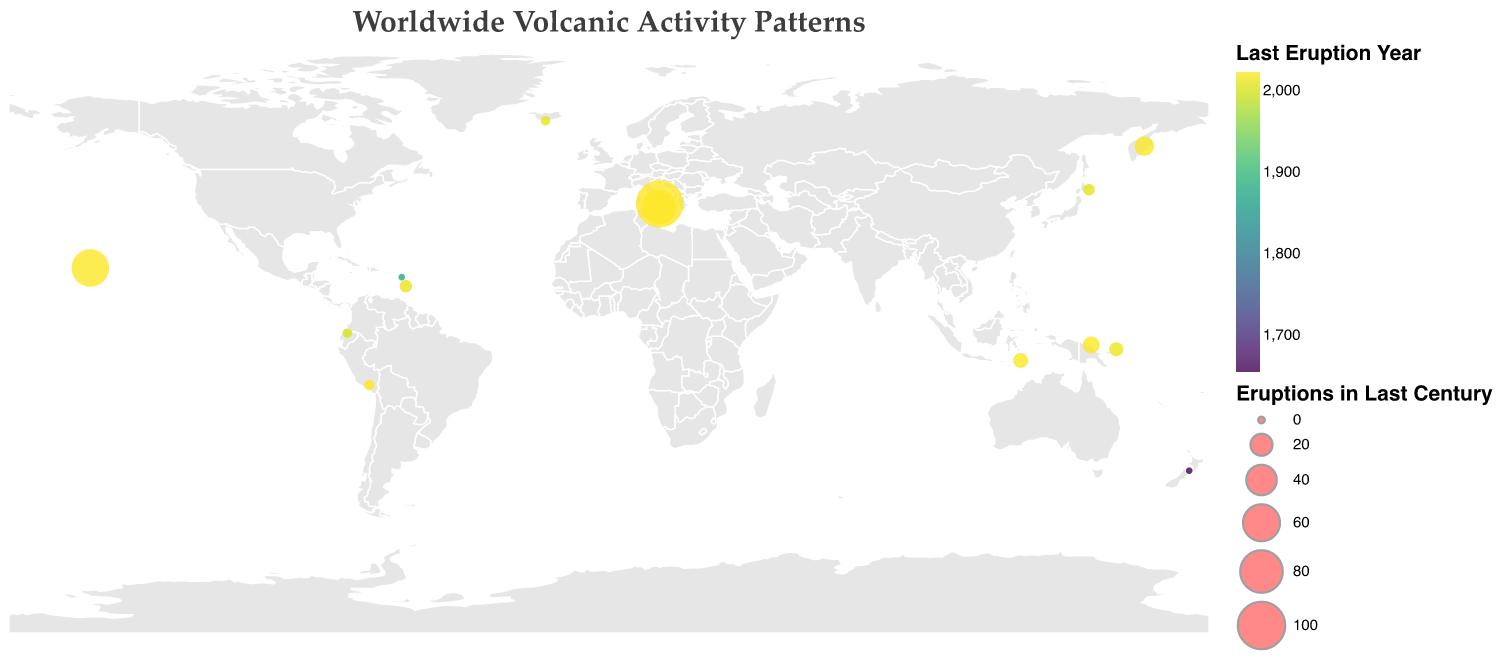Which volcano had the most eruptions in the last century? By observing the size of the circles, the largest circle represents the volcano with the most eruptions. The largest circle is for Stromboli in Italy, with "Continuous" eruptions.
Answer: Stromboli Which volcano last erupted in 2010? By looking at the tooltip or the color scale indicating the eruption year, we find Soufriere Hills in Montserrat and Eyjafjallajökull in Iceland both last erupted in 2010.
Answer: Soufriere Hills, Eyjafjallajökull How many volcanoes have not erupted in the last century? Zero eruptions are represented by the smallest circles. There are two such small circles, belonging to Taranaki in New Zealand and Morne Diablotins in Dominica.
Answer: 2 Which country has the volcano with the highest eruption frequency? By checking the tooltip and looking for the highest number of eruptions (largest circle) combined with country information, we see that Stromboli in Italy has the highest eruption frequency.
Answer: Italy What is the average number of eruptions in the last century for Papua New Guinea's volcanoes? Papua New Guinea has two volcanoes, Tavurvur and Manam, with 7 and 11 eruptions respectively. The average is calculated as (7 + 11) / 2 = 9.
Answer: 9 Which volcano was most recently active, and in what year did it last erupt? The most recent year is indicated by the most intense color on the color scale. Observing this, Kilauea, Stromboli, Mount Etna, and Shiveluch all last erupted in 2023.
Answer: Kilauea, Stromboli, Mount Etna, Shiveluch, 2023 Compare the eruption frequencies of Kilauea and Mount Etna. Which one has more eruptions, and by how many? By checking the numbers in the tooltips, Kilauea has 62 eruptions and Mount Etna has 53 eruptions in the last century. The difference is 62 - 53 = 9 eruptions.
Answer: Kilauea, 9 Which region has the highest density of active volcanoes? By visually assessing the map, observing the clusters of circles, the region around the Pacific Ring of Fire (especially Papua New Guinea and Indonesia) has a notable density of active volcanoes.
Answer: Pacific Ring of Fire How many volcanoes have erupted more than 10 times in the last century? By sizing, circles for volcanoes with more than 10 eruptions are among the larger circles. These volcanoes are Kilauea (62), Mount Etna (53), Stromboli (100 from "Continuous"), Shiveluch (15), and Manam (11), totaling five.
Answer: 5 